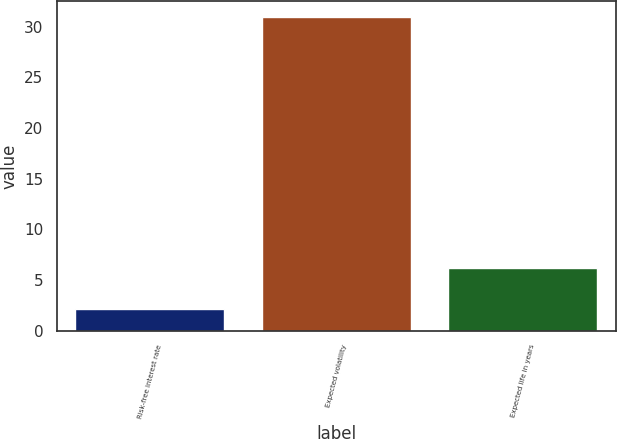Convert chart. <chart><loc_0><loc_0><loc_500><loc_500><bar_chart><fcel>Risk-free interest rate<fcel>Expected volatility<fcel>Expected life in years<nl><fcel>2.13<fcel>31<fcel>6.17<nl></chart> 